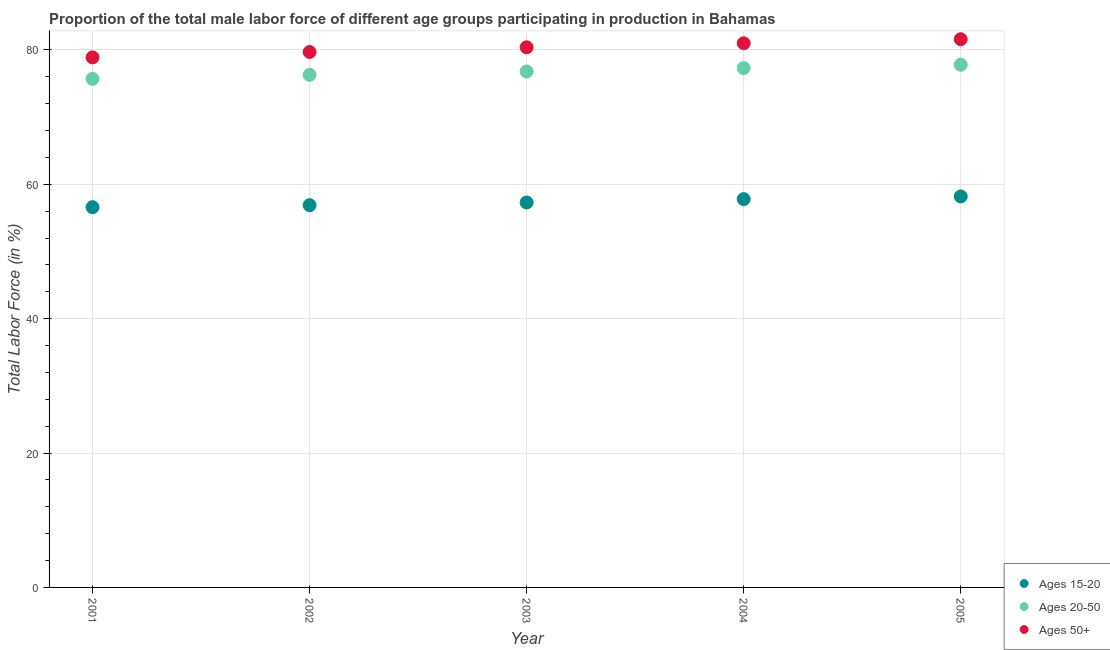Is the number of dotlines equal to the number of legend labels?
Provide a short and direct response. Yes. What is the percentage of male labor force within the age group 15-20 in 2002?
Provide a short and direct response. 56.9. Across all years, what is the maximum percentage of male labor force within the age group 15-20?
Your answer should be compact. 58.2. Across all years, what is the minimum percentage of male labor force within the age group 20-50?
Your response must be concise. 75.7. What is the total percentage of male labor force within the age group 15-20 in the graph?
Keep it short and to the point. 286.8. What is the difference between the percentage of male labor force above age 50 in 2002 and that in 2005?
Offer a very short reply. -1.9. What is the difference between the percentage of male labor force within the age group 15-20 in 2003 and the percentage of male labor force above age 50 in 2004?
Provide a short and direct response. -23.7. What is the average percentage of male labor force within the age group 15-20 per year?
Give a very brief answer. 57.36. In the year 2005, what is the difference between the percentage of male labor force within the age group 20-50 and percentage of male labor force within the age group 15-20?
Make the answer very short. 19.6. What is the ratio of the percentage of male labor force above age 50 in 2002 to that in 2004?
Keep it short and to the point. 0.98. Is the percentage of male labor force within the age group 15-20 in 2004 less than that in 2005?
Ensure brevity in your answer.  Yes. What is the difference between the highest and the second highest percentage of male labor force above age 50?
Your response must be concise. 0.6. What is the difference between the highest and the lowest percentage of male labor force within the age group 20-50?
Your answer should be very brief. 2.1. Is the percentage of male labor force within the age group 20-50 strictly less than the percentage of male labor force above age 50 over the years?
Give a very brief answer. Yes. How many years are there in the graph?
Offer a terse response. 5. Are the values on the major ticks of Y-axis written in scientific E-notation?
Make the answer very short. No. Does the graph contain any zero values?
Make the answer very short. No. Does the graph contain grids?
Give a very brief answer. Yes. Where does the legend appear in the graph?
Offer a terse response. Bottom right. How many legend labels are there?
Provide a short and direct response. 3. How are the legend labels stacked?
Ensure brevity in your answer.  Vertical. What is the title of the graph?
Provide a succinct answer. Proportion of the total male labor force of different age groups participating in production in Bahamas. What is the label or title of the X-axis?
Provide a short and direct response. Year. What is the label or title of the Y-axis?
Offer a very short reply. Total Labor Force (in %). What is the Total Labor Force (in %) in Ages 15-20 in 2001?
Make the answer very short. 56.6. What is the Total Labor Force (in %) of Ages 20-50 in 2001?
Give a very brief answer. 75.7. What is the Total Labor Force (in %) of Ages 50+ in 2001?
Provide a succinct answer. 78.9. What is the Total Labor Force (in %) of Ages 15-20 in 2002?
Give a very brief answer. 56.9. What is the Total Labor Force (in %) of Ages 20-50 in 2002?
Your answer should be compact. 76.3. What is the Total Labor Force (in %) in Ages 50+ in 2002?
Give a very brief answer. 79.7. What is the Total Labor Force (in %) of Ages 15-20 in 2003?
Ensure brevity in your answer.  57.3. What is the Total Labor Force (in %) in Ages 20-50 in 2003?
Provide a succinct answer. 76.8. What is the Total Labor Force (in %) of Ages 50+ in 2003?
Your response must be concise. 80.4. What is the Total Labor Force (in %) of Ages 15-20 in 2004?
Offer a very short reply. 57.8. What is the Total Labor Force (in %) of Ages 20-50 in 2004?
Give a very brief answer. 77.3. What is the Total Labor Force (in %) of Ages 50+ in 2004?
Give a very brief answer. 81. What is the Total Labor Force (in %) of Ages 15-20 in 2005?
Make the answer very short. 58.2. What is the Total Labor Force (in %) in Ages 20-50 in 2005?
Make the answer very short. 77.8. What is the Total Labor Force (in %) in Ages 50+ in 2005?
Make the answer very short. 81.6. Across all years, what is the maximum Total Labor Force (in %) in Ages 15-20?
Make the answer very short. 58.2. Across all years, what is the maximum Total Labor Force (in %) of Ages 20-50?
Make the answer very short. 77.8. Across all years, what is the maximum Total Labor Force (in %) in Ages 50+?
Make the answer very short. 81.6. Across all years, what is the minimum Total Labor Force (in %) of Ages 15-20?
Offer a very short reply. 56.6. Across all years, what is the minimum Total Labor Force (in %) of Ages 20-50?
Offer a very short reply. 75.7. Across all years, what is the minimum Total Labor Force (in %) in Ages 50+?
Provide a succinct answer. 78.9. What is the total Total Labor Force (in %) in Ages 15-20 in the graph?
Give a very brief answer. 286.8. What is the total Total Labor Force (in %) in Ages 20-50 in the graph?
Make the answer very short. 383.9. What is the total Total Labor Force (in %) of Ages 50+ in the graph?
Make the answer very short. 401.6. What is the difference between the Total Labor Force (in %) of Ages 15-20 in 2001 and that in 2002?
Your response must be concise. -0.3. What is the difference between the Total Labor Force (in %) in Ages 20-50 in 2001 and that in 2002?
Your answer should be very brief. -0.6. What is the difference between the Total Labor Force (in %) in Ages 20-50 in 2001 and that in 2003?
Provide a succinct answer. -1.1. What is the difference between the Total Labor Force (in %) of Ages 20-50 in 2001 and that in 2004?
Offer a very short reply. -1.6. What is the difference between the Total Labor Force (in %) of Ages 50+ in 2001 and that in 2004?
Provide a succinct answer. -2.1. What is the difference between the Total Labor Force (in %) of Ages 15-20 in 2001 and that in 2005?
Provide a short and direct response. -1.6. What is the difference between the Total Labor Force (in %) of Ages 15-20 in 2002 and that in 2003?
Provide a short and direct response. -0.4. What is the difference between the Total Labor Force (in %) in Ages 20-50 in 2002 and that in 2003?
Ensure brevity in your answer.  -0.5. What is the difference between the Total Labor Force (in %) of Ages 50+ in 2002 and that in 2003?
Your response must be concise. -0.7. What is the difference between the Total Labor Force (in %) of Ages 15-20 in 2002 and that in 2004?
Make the answer very short. -0.9. What is the difference between the Total Labor Force (in %) of Ages 20-50 in 2002 and that in 2004?
Offer a very short reply. -1. What is the difference between the Total Labor Force (in %) in Ages 50+ in 2002 and that in 2004?
Provide a succinct answer. -1.3. What is the difference between the Total Labor Force (in %) in Ages 50+ in 2002 and that in 2005?
Your response must be concise. -1.9. What is the difference between the Total Labor Force (in %) in Ages 15-20 in 2003 and that in 2005?
Keep it short and to the point. -0.9. What is the difference between the Total Labor Force (in %) in Ages 20-50 in 2003 and that in 2005?
Give a very brief answer. -1. What is the difference between the Total Labor Force (in %) of Ages 20-50 in 2004 and that in 2005?
Provide a short and direct response. -0.5. What is the difference between the Total Labor Force (in %) of Ages 50+ in 2004 and that in 2005?
Keep it short and to the point. -0.6. What is the difference between the Total Labor Force (in %) of Ages 15-20 in 2001 and the Total Labor Force (in %) of Ages 20-50 in 2002?
Your answer should be very brief. -19.7. What is the difference between the Total Labor Force (in %) of Ages 15-20 in 2001 and the Total Labor Force (in %) of Ages 50+ in 2002?
Keep it short and to the point. -23.1. What is the difference between the Total Labor Force (in %) in Ages 15-20 in 2001 and the Total Labor Force (in %) in Ages 20-50 in 2003?
Offer a terse response. -20.2. What is the difference between the Total Labor Force (in %) of Ages 15-20 in 2001 and the Total Labor Force (in %) of Ages 50+ in 2003?
Make the answer very short. -23.8. What is the difference between the Total Labor Force (in %) in Ages 15-20 in 2001 and the Total Labor Force (in %) in Ages 20-50 in 2004?
Make the answer very short. -20.7. What is the difference between the Total Labor Force (in %) of Ages 15-20 in 2001 and the Total Labor Force (in %) of Ages 50+ in 2004?
Provide a short and direct response. -24.4. What is the difference between the Total Labor Force (in %) in Ages 20-50 in 2001 and the Total Labor Force (in %) in Ages 50+ in 2004?
Make the answer very short. -5.3. What is the difference between the Total Labor Force (in %) in Ages 15-20 in 2001 and the Total Labor Force (in %) in Ages 20-50 in 2005?
Offer a terse response. -21.2. What is the difference between the Total Labor Force (in %) of Ages 15-20 in 2001 and the Total Labor Force (in %) of Ages 50+ in 2005?
Your answer should be compact. -25. What is the difference between the Total Labor Force (in %) of Ages 20-50 in 2001 and the Total Labor Force (in %) of Ages 50+ in 2005?
Provide a succinct answer. -5.9. What is the difference between the Total Labor Force (in %) in Ages 15-20 in 2002 and the Total Labor Force (in %) in Ages 20-50 in 2003?
Give a very brief answer. -19.9. What is the difference between the Total Labor Force (in %) in Ages 15-20 in 2002 and the Total Labor Force (in %) in Ages 50+ in 2003?
Keep it short and to the point. -23.5. What is the difference between the Total Labor Force (in %) of Ages 20-50 in 2002 and the Total Labor Force (in %) of Ages 50+ in 2003?
Ensure brevity in your answer.  -4.1. What is the difference between the Total Labor Force (in %) in Ages 15-20 in 2002 and the Total Labor Force (in %) in Ages 20-50 in 2004?
Provide a short and direct response. -20.4. What is the difference between the Total Labor Force (in %) of Ages 15-20 in 2002 and the Total Labor Force (in %) of Ages 50+ in 2004?
Keep it short and to the point. -24.1. What is the difference between the Total Labor Force (in %) of Ages 15-20 in 2002 and the Total Labor Force (in %) of Ages 20-50 in 2005?
Provide a succinct answer. -20.9. What is the difference between the Total Labor Force (in %) in Ages 15-20 in 2002 and the Total Labor Force (in %) in Ages 50+ in 2005?
Your answer should be very brief. -24.7. What is the difference between the Total Labor Force (in %) in Ages 20-50 in 2002 and the Total Labor Force (in %) in Ages 50+ in 2005?
Offer a very short reply. -5.3. What is the difference between the Total Labor Force (in %) of Ages 15-20 in 2003 and the Total Labor Force (in %) of Ages 20-50 in 2004?
Keep it short and to the point. -20. What is the difference between the Total Labor Force (in %) in Ages 15-20 in 2003 and the Total Labor Force (in %) in Ages 50+ in 2004?
Make the answer very short. -23.7. What is the difference between the Total Labor Force (in %) of Ages 20-50 in 2003 and the Total Labor Force (in %) of Ages 50+ in 2004?
Make the answer very short. -4.2. What is the difference between the Total Labor Force (in %) of Ages 15-20 in 2003 and the Total Labor Force (in %) of Ages 20-50 in 2005?
Offer a terse response. -20.5. What is the difference between the Total Labor Force (in %) of Ages 15-20 in 2003 and the Total Labor Force (in %) of Ages 50+ in 2005?
Offer a very short reply. -24.3. What is the difference between the Total Labor Force (in %) of Ages 20-50 in 2003 and the Total Labor Force (in %) of Ages 50+ in 2005?
Make the answer very short. -4.8. What is the difference between the Total Labor Force (in %) of Ages 15-20 in 2004 and the Total Labor Force (in %) of Ages 20-50 in 2005?
Offer a terse response. -20. What is the difference between the Total Labor Force (in %) in Ages 15-20 in 2004 and the Total Labor Force (in %) in Ages 50+ in 2005?
Your answer should be very brief. -23.8. What is the difference between the Total Labor Force (in %) of Ages 20-50 in 2004 and the Total Labor Force (in %) of Ages 50+ in 2005?
Your answer should be compact. -4.3. What is the average Total Labor Force (in %) in Ages 15-20 per year?
Offer a terse response. 57.36. What is the average Total Labor Force (in %) in Ages 20-50 per year?
Keep it short and to the point. 76.78. What is the average Total Labor Force (in %) in Ages 50+ per year?
Your answer should be very brief. 80.32. In the year 2001, what is the difference between the Total Labor Force (in %) in Ages 15-20 and Total Labor Force (in %) in Ages 20-50?
Provide a short and direct response. -19.1. In the year 2001, what is the difference between the Total Labor Force (in %) of Ages 15-20 and Total Labor Force (in %) of Ages 50+?
Your answer should be very brief. -22.3. In the year 2002, what is the difference between the Total Labor Force (in %) in Ages 15-20 and Total Labor Force (in %) in Ages 20-50?
Provide a short and direct response. -19.4. In the year 2002, what is the difference between the Total Labor Force (in %) of Ages 15-20 and Total Labor Force (in %) of Ages 50+?
Make the answer very short. -22.8. In the year 2002, what is the difference between the Total Labor Force (in %) in Ages 20-50 and Total Labor Force (in %) in Ages 50+?
Provide a short and direct response. -3.4. In the year 2003, what is the difference between the Total Labor Force (in %) of Ages 15-20 and Total Labor Force (in %) of Ages 20-50?
Offer a very short reply. -19.5. In the year 2003, what is the difference between the Total Labor Force (in %) of Ages 15-20 and Total Labor Force (in %) of Ages 50+?
Offer a terse response. -23.1. In the year 2003, what is the difference between the Total Labor Force (in %) of Ages 20-50 and Total Labor Force (in %) of Ages 50+?
Offer a very short reply. -3.6. In the year 2004, what is the difference between the Total Labor Force (in %) of Ages 15-20 and Total Labor Force (in %) of Ages 20-50?
Give a very brief answer. -19.5. In the year 2004, what is the difference between the Total Labor Force (in %) in Ages 15-20 and Total Labor Force (in %) in Ages 50+?
Your response must be concise. -23.2. In the year 2005, what is the difference between the Total Labor Force (in %) of Ages 15-20 and Total Labor Force (in %) of Ages 20-50?
Make the answer very short. -19.6. In the year 2005, what is the difference between the Total Labor Force (in %) in Ages 15-20 and Total Labor Force (in %) in Ages 50+?
Give a very brief answer. -23.4. In the year 2005, what is the difference between the Total Labor Force (in %) in Ages 20-50 and Total Labor Force (in %) in Ages 50+?
Keep it short and to the point. -3.8. What is the ratio of the Total Labor Force (in %) in Ages 15-20 in 2001 to that in 2002?
Give a very brief answer. 0.99. What is the ratio of the Total Labor Force (in %) in Ages 20-50 in 2001 to that in 2002?
Give a very brief answer. 0.99. What is the ratio of the Total Labor Force (in %) in Ages 50+ in 2001 to that in 2002?
Offer a very short reply. 0.99. What is the ratio of the Total Labor Force (in %) in Ages 15-20 in 2001 to that in 2003?
Provide a succinct answer. 0.99. What is the ratio of the Total Labor Force (in %) in Ages 20-50 in 2001 to that in 2003?
Your answer should be very brief. 0.99. What is the ratio of the Total Labor Force (in %) in Ages 50+ in 2001 to that in 2003?
Your answer should be compact. 0.98. What is the ratio of the Total Labor Force (in %) of Ages 15-20 in 2001 to that in 2004?
Make the answer very short. 0.98. What is the ratio of the Total Labor Force (in %) of Ages 20-50 in 2001 to that in 2004?
Give a very brief answer. 0.98. What is the ratio of the Total Labor Force (in %) of Ages 50+ in 2001 to that in 2004?
Offer a terse response. 0.97. What is the ratio of the Total Labor Force (in %) in Ages 15-20 in 2001 to that in 2005?
Ensure brevity in your answer.  0.97. What is the ratio of the Total Labor Force (in %) of Ages 20-50 in 2001 to that in 2005?
Provide a short and direct response. 0.97. What is the ratio of the Total Labor Force (in %) of Ages 50+ in 2001 to that in 2005?
Offer a very short reply. 0.97. What is the ratio of the Total Labor Force (in %) of Ages 15-20 in 2002 to that in 2003?
Keep it short and to the point. 0.99. What is the ratio of the Total Labor Force (in %) of Ages 15-20 in 2002 to that in 2004?
Offer a very short reply. 0.98. What is the ratio of the Total Labor Force (in %) of Ages 20-50 in 2002 to that in 2004?
Your answer should be very brief. 0.99. What is the ratio of the Total Labor Force (in %) of Ages 50+ in 2002 to that in 2004?
Make the answer very short. 0.98. What is the ratio of the Total Labor Force (in %) of Ages 15-20 in 2002 to that in 2005?
Make the answer very short. 0.98. What is the ratio of the Total Labor Force (in %) in Ages 20-50 in 2002 to that in 2005?
Make the answer very short. 0.98. What is the ratio of the Total Labor Force (in %) of Ages 50+ in 2002 to that in 2005?
Provide a short and direct response. 0.98. What is the ratio of the Total Labor Force (in %) in Ages 20-50 in 2003 to that in 2004?
Offer a very short reply. 0.99. What is the ratio of the Total Labor Force (in %) in Ages 50+ in 2003 to that in 2004?
Offer a terse response. 0.99. What is the ratio of the Total Labor Force (in %) of Ages 15-20 in 2003 to that in 2005?
Ensure brevity in your answer.  0.98. What is the ratio of the Total Labor Force (in %) in Ages 20-50 in 2003 to that in 2005?
Keep it short and to the point. 0.99. What is the difference between the highest and the lowest Total Labor Force (in %) of Ages 50+?
Give a very brief answer. 2.7. 